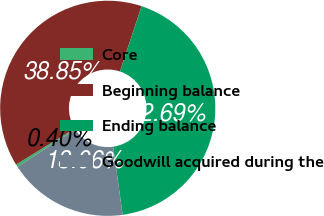Convert chart to OTSL. <chart><loc_0><loc_0><loc_500><loc_500><pie_chart><fcel>Core<fcel>Beginning balance<fcel>Ending balance<fcel>Goodwill acquired during the<nl><fcel>0.4%<fcel>38.85%<fcel>42.69%<fcel>18.06%<nl></chart> 